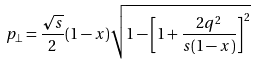Convert formula to latex. <formula><loc_0><loc_0><loc_500><loc_500>p _ { \perp } = \frac { \sqrt { s } } { 2 } ( 1 - x ) \sqrt { 1 - \left [ 1 + \frac { 2 q ^ { 2 } } { s ( 1 - x ) } \right ] ^ { 2 } }</formula> 